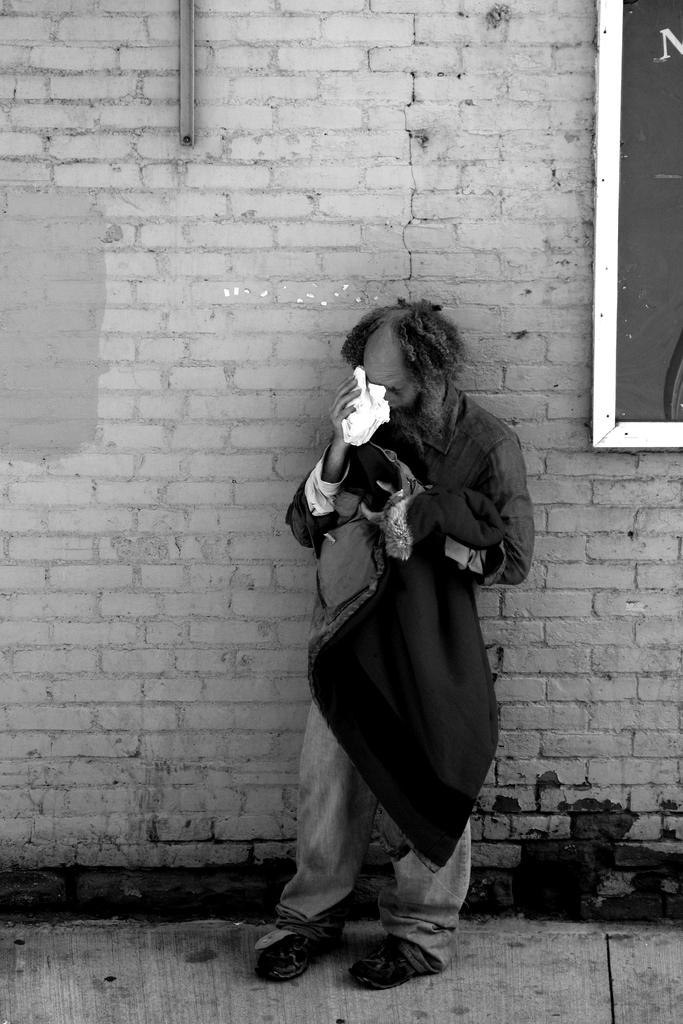What is the main subject of the image? There is a person in the image. What is the person doing in the image? The person is standing and holding clothes. What can be seen in the background of the image? There is a wall in the background of the image. Is there anything attached to the wall in the image? Yes, there is a board attached to the wall. What type of statement is written on the bottle in the image? There is no bottle present in the image, so it is not possible to answer that question. 